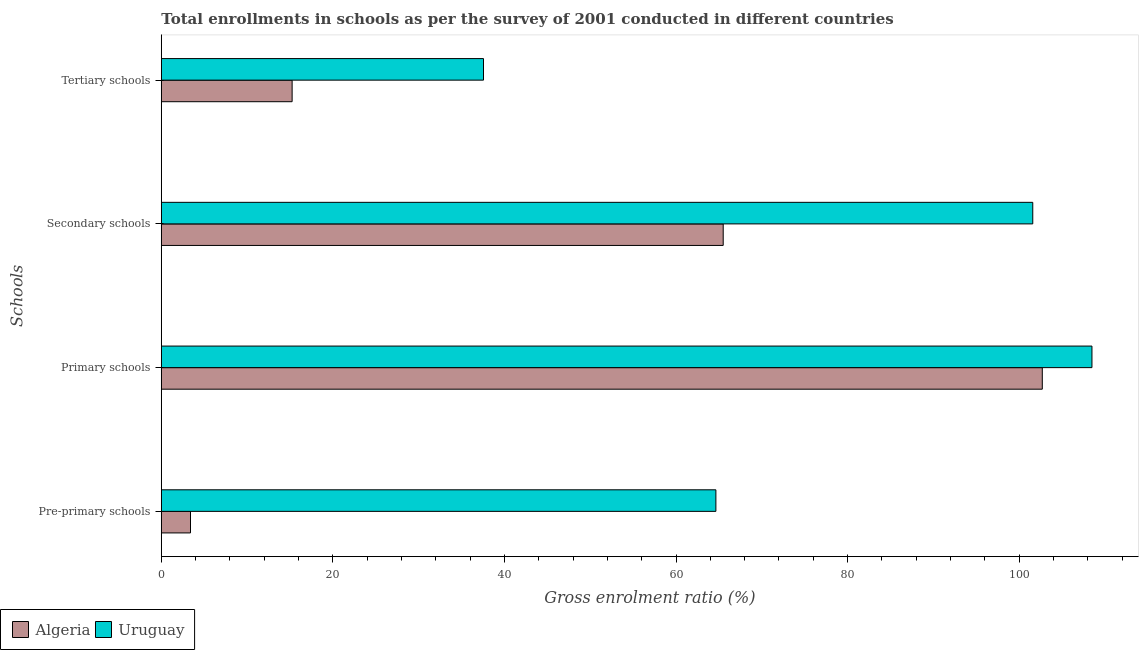How many different coloured bars are there?
Ensure brevity in your answer.  2. Are the number of bars on each tick of the Y-axis equal?
Offer a very short reply. Yes. How many bars are there on the 1st tick from the bottom?
Give a very brief answer. 2. What is the label of the 1st group of bars from the top?
Ensure brevity in your answer.  Tertiary schools. What is the gross enrolment ratio in secondary schools in Algeria?
Provide a succinct answer. 65.5. Across all countries, what is the maximum gross enrolment ratio in primary schools?
Provide a succinct answer. 108.48. Across all countries, what is the minimum gross enrolment ratio in primary schools?
Provide a short and direct response. 102.69. In which country was the gross enrolment ratio in tertiary schools maximum?
Provide a succinct answer. Uruguay. In which country was the gross enrolment ratio in secondary schools minimum?
Your answer should be very brief. Algeria. What is the total gross enrolment ratio in pre-primary schools in the graph?
Keep it short and to the point. 68.05. What is the difference between the gross enrolment ratio in pre-primary schools in Algeria and that in Uruguay?
Keep it short and to the point. -61.24. What is the difference between the gross enrolment ratio in pre-primary schools in Uruguay and the gross enrolment ratio in primary schools in Algeria?
Your answer should be very brief. -38.05. What is the average gross enrolment ratio in tertiary schools per country?
Your answer should be very brief. 26.4. What is the difference between the gross enrolment ratio in primary schools and gross enrolment ratio in secondary schools in Uruguay?
Make the answer very short. 6.9. What is the ratio of the gross enrolment ratio in pre-primary schools in Algeria to that in Uruguay?
Keep it short and to the point. 0.05. Is the gross enrolment ratio in tertiary schools in Algeria less than that in Uruguay?
Provide a succinct answer. Yes. What is the difference between the highest and the second highest gross enrolment ratio in primary schools?
Provide a succinct answer. 5.79. What is the difference between the highest and the lowest gross enrolment ratio in secondary schools?
Give a very brief answer. 36.09. In how many countries, is the gross enrolment ratio in secondary schools greater than the average gross enrolment ratio in secondary schools taken over all countries?
Your response must be concise. 1. Is the sum of the gross enrolment ratio in secondary schools in Uruguay and Algeria greater than the maximum gross enrolment ratio in primary schools across all countries?
Provide a short and direct response. Yes. Is it the case that in every country, the sum of the gross enrolment ratio in tertiary schools and gross enrolment ratio in secondary schools is greater than the sum of gross enrolment ratio in pre-primary schools and gross enrolment ratio in primary schools?
Offer a terse response. Yes. What does the 2nd bar from the top in Tertiary schools represents?
Make the answer very short. Algeria. What does the 1st bar from the bottom in Tertiary schools represents?
Provide a short and direct response. Algeria. Is it the case that in every country, the sum of the gross enrolment ratio in pre-primary schools and gross enrolment ratio in primary schools is greater than the gross enrolment ratio in secondary schools?
Ensure brevity in your answer.  Yes. How many countries are there in the graph?
Give a very brief answer. 2. What is the difference between two consecutive major ticks on the X-axis?
Your answer should be very brief. 20. Does the graph contain grids?
Keep it short and to the point. No. Where does the legend appear in the graph?
Offer a terse response. Bottom left. What is the title of the graph?
Keep it short and to the point. Total enrollments in schools as per the survey of 2001 conducted in different countries. What is the label or title of the X-axis?
Make the answer very short. Gross enrolment ratio (%). What is the label or title of the Y-axis?
Provide a short and direct response. Schools. What is the Gross enrolment ratio (%) of Algeria in Pre-primary schools?
Your answer should be very brief. 3.4. What is the Gross enrolment ratio (%) of Uruguay in Pre-primary schools?
Your response must be concise. 64.64. What is the Gross enrolment ratio (%) of Algeria in Primary schools?
Give a very brief answer. 102.69. What is the Gross enrolment ratio (%) of Uruguay in Primary schools?
Provide a succinct answer. 108.48. What is the Gross enrolment ratio (%) of Algeria in Secondary schools?
Provide a short and direct response. 65.5. What is the Gross enrolment ratio (%) in Uruguay in Secondary schools?
Your response must be concise. 101.58. What is the Gross enrolment ratio (%) of Algeria in Tertiary schools?
Keep it short and to the point. 15.25. What is the Gross enrolment ratio (%) in Uruguay in Tertiary schools?
Your response must be concise. 37.56. Across all Schools, what is the maximum Gross enrolment ratio (%) in Algeria?
Your response must be concise. 102.69. Across all Schools, what is the maximum Gross enrolment ratio (%) in Uruguay?
Keep it short and to the point. 108.48. Across all Schools, what is the minimum Gross enrolment ratio (%) in Algeria?
Offer a terse response. 3.4. Across all Schools, what is the minimum Gross enrolment ratio (%) of Uruguay?
Offer a terse response. 37.56. What is the total Gross enrolment ratio (%) of Algeria in the graph?
Offer a very short reply. 186.84. What is the total Gross enrolment ratio (%) in Uruguay in the graph?
Offer a very short reply. 312.26. What is the difference between the Gross enrolment ratio (%) in Algeria in Pre-primary schools and that in Primary schools?
Provide a succinct answer. -99.29. What is the difference between the Gross enrolment ratio (%) in Uruguay in Pre-primary schools and that in Primary schools?
Provide a short and direct response. -43.84. What is the difference between the Gross enrolment ratio (%) in Algeria in Pre-primary schools and that in Secondary schools?
Keep it short and to the point. -62.1. What is the difference between the Gross enrolment ratio (%) in Uruguay in Pre-primary schools and that in Secondary schools?
Keep it short and to the point. -36.94. What is the difference between the Gross enrolment ratio (%) of Algeria in Pre-primary schools and that in Tertiary schools?
Ensure brevity in your answer.  -11.85. What is the difference between the Gross enrolment ratio (%) in Uruguay in Pre-primary schools and that in Tertiary schools?
Provide a succinct answer. 27.09. What is the difference between the Gross enrolment ratio (%) in Algeria in Primary schools and that in Secondary schools?
Make the answer very short. 37.2. What is the difference between the Gross enrolment ratio (%) of Uruguay in Primary schools and that in Secondary schools?
Keep it short and to the point. 6.9. What is the difference between the Gross enrolment ratio (%) in Algeria in Primary schools and that in Tertiary schools?
Offer a terse response. 87.45. What is the difference between the Gross enrolment ratio (%) in Uruguay in Primary schools and that in Tertiary schools?
Provide a short and direct response. 70.93. What is the difference between the Gross enrolment ratio (%) in Algeria in Secondary schools and that in Tertiary schools?
Keep it short and to the point. 50.25. What is the difference between the Gross enrolment ratio (%) of Uruguay in Secondary schools and that in Tertiary schools?
Offer a very short reply. 64.03. What is the difference between the Gross enrolment ratio (%) in Algeria in Pre-primary schools and the Gross enrolment ratio (%) in Uruguay in Primary schools?
Your answer should be compact. -105.08. What is the difference between the Gross enrolment ratio (%) in Algeria in Pre-primary schools and the Gross enrolment ratio (%) in Uruguay in Secondary schools?
Give a very brief answer. -98.18. What is the difference between the Gross enrolment ratio (%) of Algeria in Pre-primary schools and the Gross enrolment ratio (%) of Uruguay in Tertiary schools?
Offer a terse response. -34.15. What is the difference between the Gross enrolment ratio (%) in Algeria in Primary schools and the Gross enrolment ratio (%) in Uruguay in Secondary schools?
Offer a very short reply. 1.11. What is the difference between the Gross enrolment ratio (%) of Algeria in Primary schools and the Gross enrolment ratio (%) of Uruguay in Tertiary schools?
Keep it short and to the point. 65.14. What is the difference between the Gross enrolment ratio (%) of Algeria in Secondary schools and the Gross enrolment ratio (%) of Uruguay in Tertiary schools?
Offer a very short reply. 27.94. What is the average Gross enrolment ratio (%) in Algeria per Schools?
Your answer should be very brief. 46.71. What is the average Gross enrolment ratio (%) in Uruguay per Schools?
Provide a succinct answer. 78.07. What is the difference between the Gross enrolment ratio (%) in Algeria and Gross enrolment ratio (%) in Uruguay in Pre-primary schools?
Your response must be concise. -61.24. What is the difference between the Gross enrolment ratio (%) in Algeria and Gross enrolment ratio (%) in Uruguay in Primary schools?
Your answer should be compact. -5.79. What is the difference between the Gross enrolment ratio (%) of Algeria and Gross enrolment ratio (%) of Uruguay in Secondary schools?
Offer a very short reply. -36.09. What is the difference between the Gross enrolment ratio (%) in Algeria and Gross enrolment ratio (%) in Uruguay in Tertiary schools?
Ensure brevity in your answer.  -22.31. What is the ratio of the Gross enrolment ratio (%) of Algeria in Pre-primary schools to that in Primary schools?
Offer a terse response. 0.03. What is the ratio of the Gross enrolment ratio (%) in Uruguay in Pre-primary schools to that in Primary schools?
Make the answer very short. 0.6. What is the ratio of the Gross enrolment ratio (%) in Algeria in Pre-primary schools to that in Secondary schools?
Offer a terse response. 0.05. What is the ratio of the Gross enrolment ratio (%) of Uruguay in Pre-primary schools to that in Secondary schools?
Give a very brief answer. 0.64. What is the ratio of the Gross enrolment ratio (%) of Algeria in Pre-primary schools to that in Tertiary schools?
Your answer should be compact. 0.22. What is the ratio of the Gross enrolment ratio (%) of Uruguay in Pre-primary schools to that in Tertiary schools?
Provide a succinct answer. 1.72. What is the ratio of the Gross enrolment ratio (%) in Algeria in Primary schools to that in Secondary schools?
Your answer should be compact. 1.57. What is the ratio of the Gross enrolment ratio (%) in Uruguay in Primary schools to that in Secondary schools?
Make the answer very short. 1.07. What is the ratio of the Gross enrolment ratio (%) in Algeria in Primary schools to that in Tertiary schools?
Provide a short and direct response. 6.73. What is the ratio of the Gross enrolment ratio (%) in Uruguay in Primary schools to that in Tertiary schools?
Provide a short and direct response. 2.89. What is the ratio of the Gross enrolment ratio (%) of Algeria in Secondary schools to that in Tertiary schools?
Keep it short and to the point. 4.3. What is the ratio of the Gross enrolment ratio (%) in Uruguay in Secondary schools to that in Tertiary schools?
Offer a very short reply. 2.7. What is the difference between the highest and the second highest Gross enrolment ratio (%) in Algeria?
Offer a terse response. 37.2. What is the difference between the highest and the second highest Gross enrolment ratio (%) in Uruguay?
Your answer should be compact. 6.9. What is the difference between the highest and the lowest Gross enrolment ratio (%) in Algeria?
Provide a short and direct response. 99.29. What is the difference between the highest and the lowest Gross enrolment ratio (%) in Uruguay?
Provide a short and direct response. 70.93. 